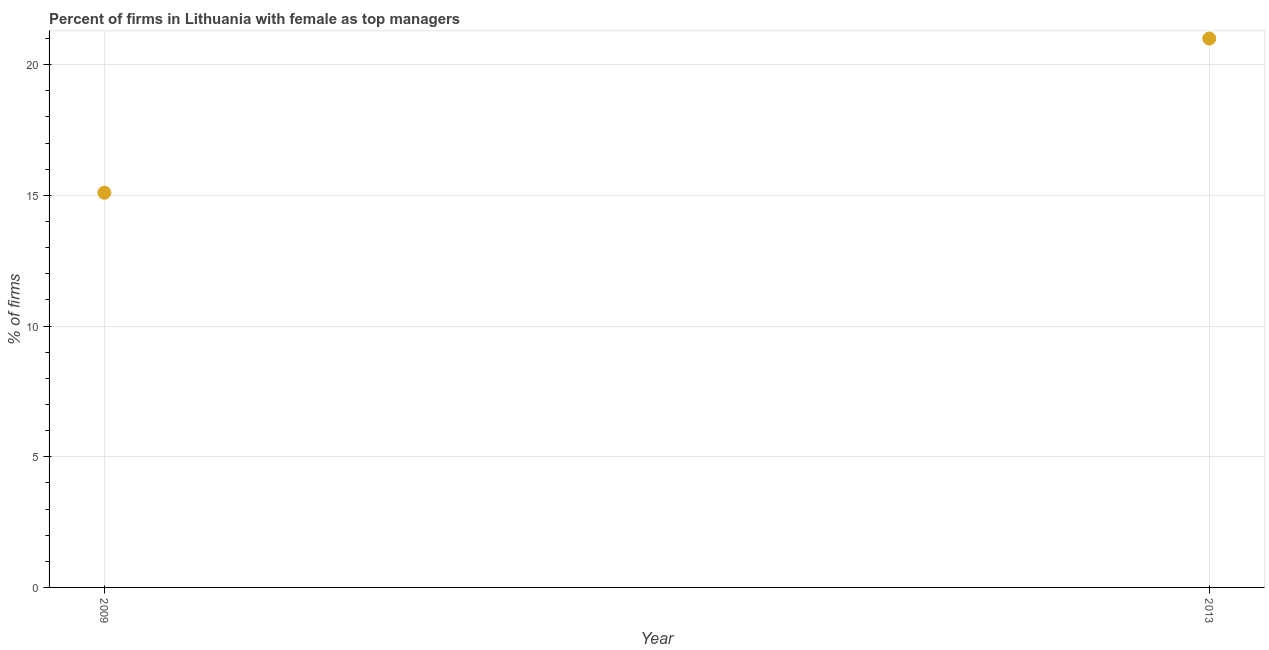What is the percentage of firms with female as top manager in 2009?
Your response must be concise. 15.1. Across all years, what is the minimum percentage of firms with female as top manager?
Offer a terse response. 15.1. In which year was the percentage of firms with female as top manager maximum?
Give a very brief answer. 2013. In which year was the percentage of firms with female as top manager minimum?
Offer a very short reply. 2009. What is the sum of the percentage of firms with female as top manager?
Provide a short and direct response. 36.1. What is the average percentage of firms with female as top manager per year?
Ensure brevity in your answer.  18.05. What is the median percentage of firms with female as top manager?
Give a very brief answer. 18.05. In how many years, is the percentage of firms with female as top manager greater than 14 %?
Give a very brief answer. 2. Do a majority of the years between 2009 and 2013 (inclusive) have percentage of firms with female as top manager greater than 4 %?
Your response must be concise. Yes. What is the ratio of the percentage of firms with female as top manager in 2009 to that in 2013?
Your answer should be compact. 0.72. Is the percentage of firms with female as top manager in 2009 less than that in 2013?
Your response must be concise. Yes. In how many years, is the percentage of firms with female as top manager greater than the average percentage of firms with female as top manager taken over all years?
Your answer should be compact. 1. How many dotlines are there?
Provide a short and direct response. 1. How many years are there in the graph?
Your answer should be very brief. 2. Does the graph contain grids?
Your answer should be compact. Yes. What is the title of the graph?
Provide a short and direct response. Percent of firms in Lithuania with female as top managers. What is the label or title of the Y-axis?
Provide a succinct answer. % of firms. What is the difference between the % of firms in 2009 and 2013?
Offer a very short reply. -5.9. What is the ratio of the % of firms in 2009 to that in 2013?
Ensure brevity in your answer.  0.72. 